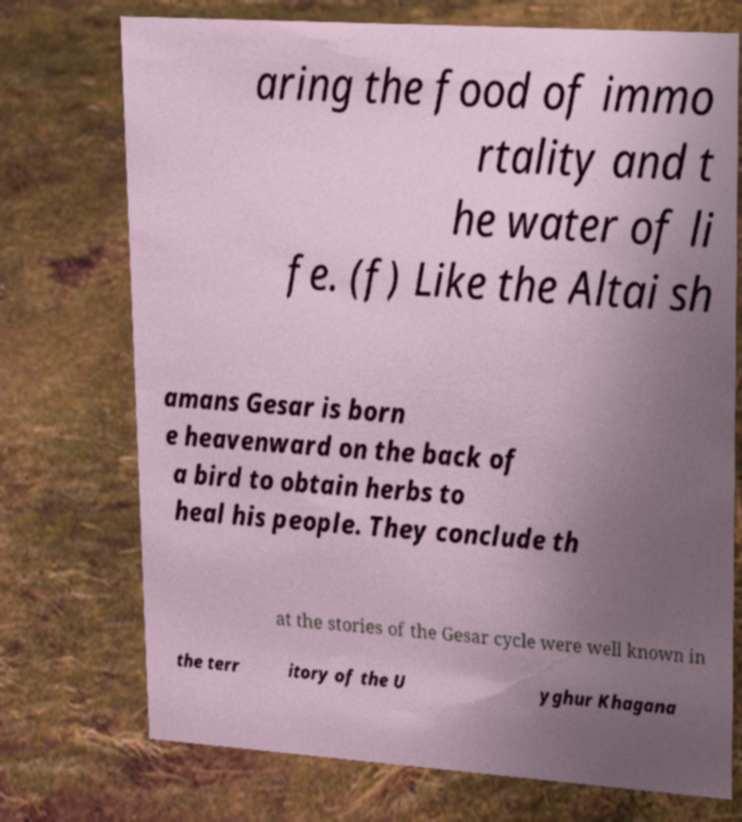Please identify and transcribe the text found in this image. aring the food of immo rtality and t he water of li fe. (f) Like the Altai sh amans Gesar is born e heavenward on the back of a bird to obtain herbs to heal his people. They conclude th at the stories of the Gesar cycle were well known in the terr itory of the U yghur Khagana 